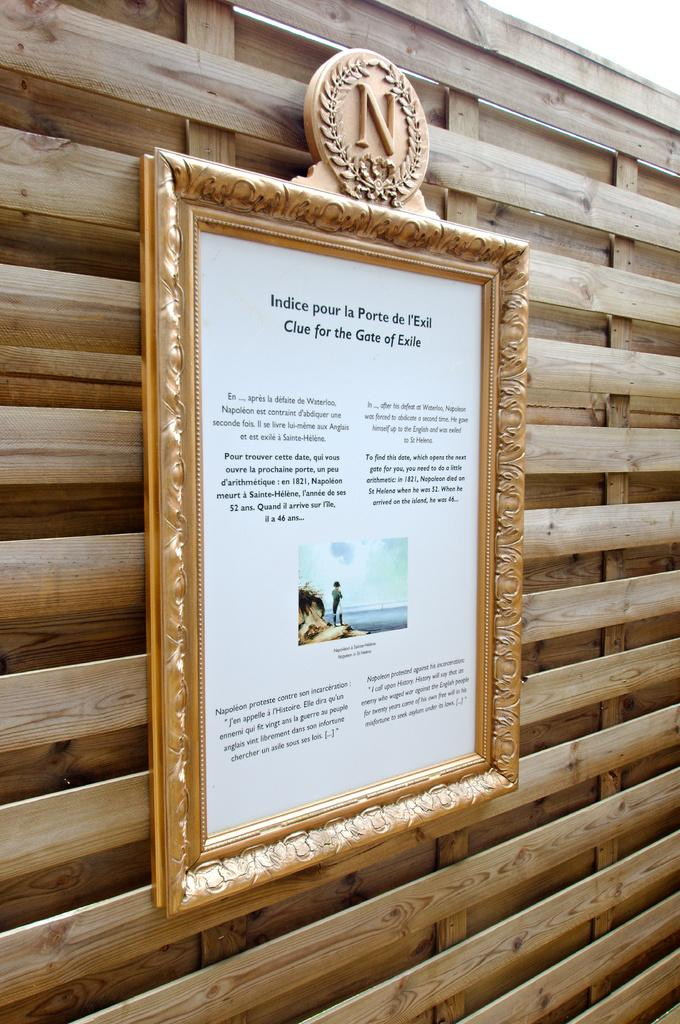<image>
Render a clear and concise summary of the photo. Gold picture frame with N on top and a writing about clue for the gate of exile. 